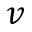<formula> <loc_0><loc_0><loc_500><loc_500>v</formula> 